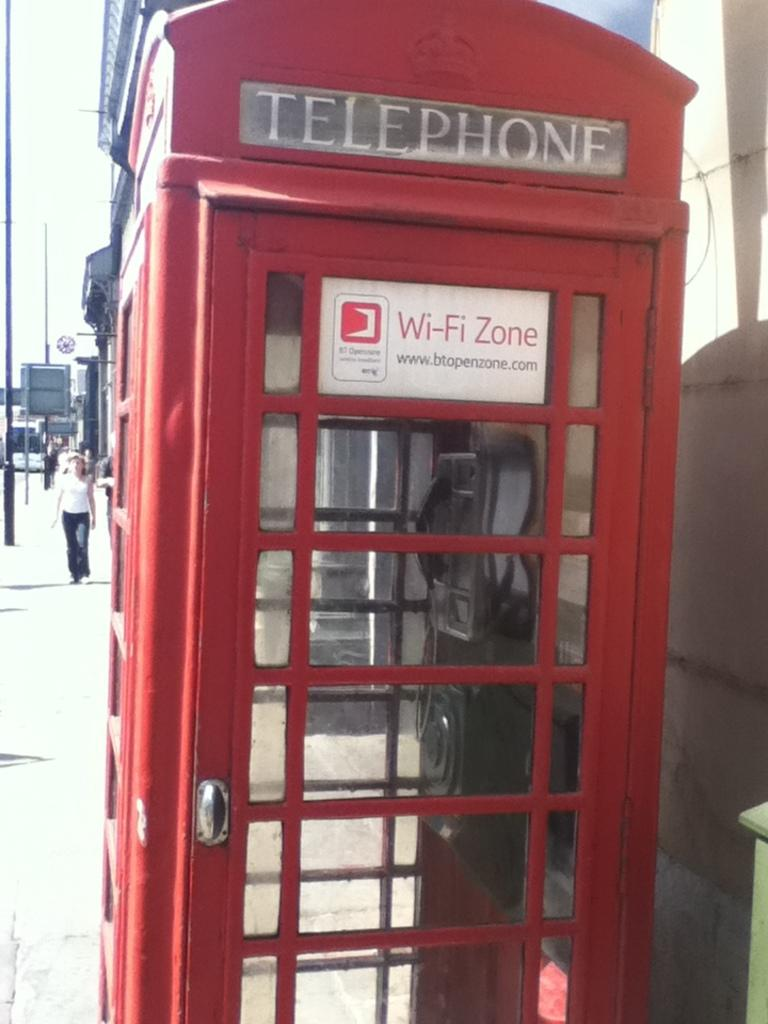<image>
Share a concise interpretation of the image provided. The red telephone booth is a wireless hotspot. 